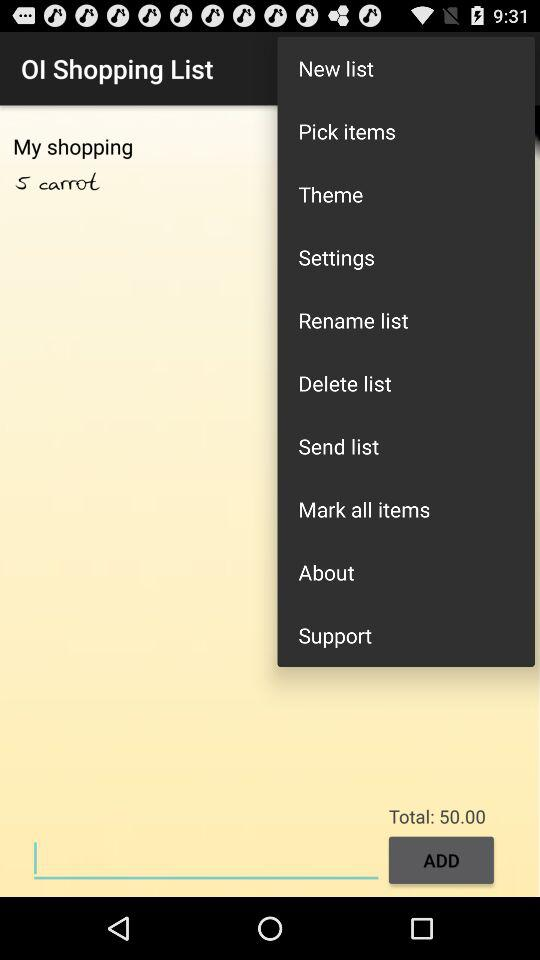What is the number of carrots written in the list? The number of carrots is 5. 